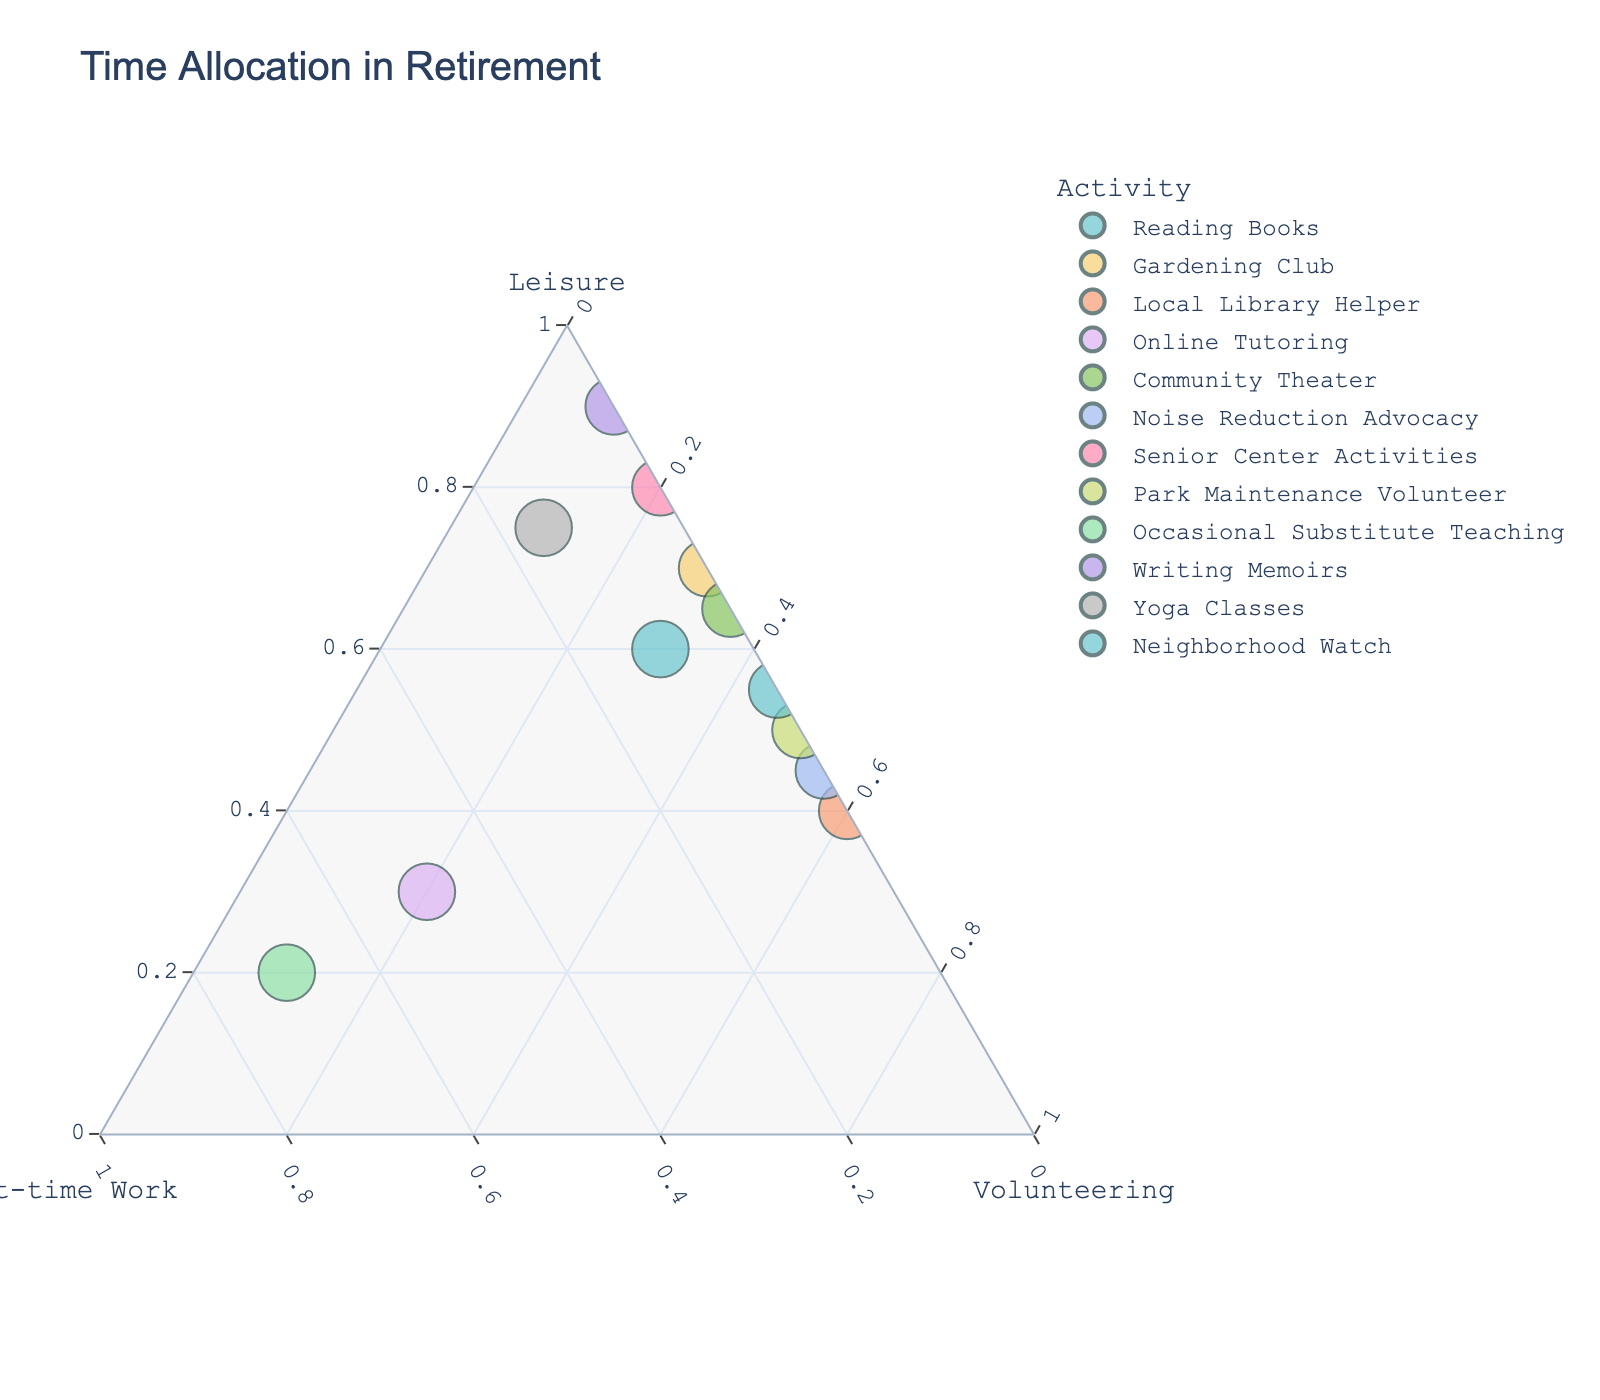Which activity has the highest allocation of leisure time? The activity with the point closest to the "Leisure" apex will have the highest percentage of leisure time. This can be identified as "Writing Memoirs" with a leisure time allocation of 90%.
Answer: Writing Memoirs How many activities show no allocation towards part-time work? Points along the base of the triangle (opposite the "Part-time Work" apex) represent activities with 0% in part-time work. These activities are "Gardening Club," "Local Library Helper," "Community Theater," "Noise Reduction Advocacy," "Senior Center Activities," "Park Maintenance Volunteer," "Neighborhood Watch," and "Writing Memoirs." Counting them gives 8 activities.
Answer: 8 Which activity has the highest combined allocation to volunteering and leisure? To find this, we add the values of leisure and volunteering for each activity. "Writing Memoirs" (90% leisure, 10% volunteering) = 100%, "Reading Books" (60% leisure, 30% volunteering) = 90%, and so on. "Writing Memoirs" sums to 100%.
Answer: Writing Memoirs Compare "Reading Books" and "Occasional Substitute Teaching." Which one spends more time on part-time work? By looking at "Reading Books" and "Occasional Substitute Teaching," the point for "Occasional Substitute Teaching" is closer to the "Part-time Work" apex at 70%, while "Reading Books" is at 10%.
Answer: Occasional Substitute Teaching Identify the activity with the most balanced time allocation among leisure, part-time work, and volunteering. The activity that appears closest to the center of the triangle would be the most balanced. Online Tutoring has a noticeable balanced allocation with 30% leisure, 50% part-time work, and 20% volunteering.
Answer: Online Tutoring Which activity is represented with 75% of its time allocated to leisure? The point that is three-quarters of the way up from the base towards the "Leisure" apex at 75% is "Yoga Classes."
Answer: Yoga Classes Which activities have exactly 50% of their time devoted to volunteering? Points that lie on the line extending from the midpoint of the "Volunteering" side to the apex have a 50% volunteering allocation: "Park Maintenance Volunteer" and "Noise Reduction Advocacy."
Answer: Park Maintenance Volunteer, Noise Reduction Advocacy What's the average percentage allocation to volunteering across all activities? Add the volunteering percentages across all activities: (30 + 30 + 60 + 20 + 35 + 55 + 20 + 50 + 10 + 10 + 10 + 45) = 375. Divide by the number of activities (12). Average = 375 / 12 = 31.25%.
Answer: 31.25% 